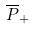<formula> <loc_0><loc_0><loc_500><loc_500>\overline { P } _ { + }</formula> 